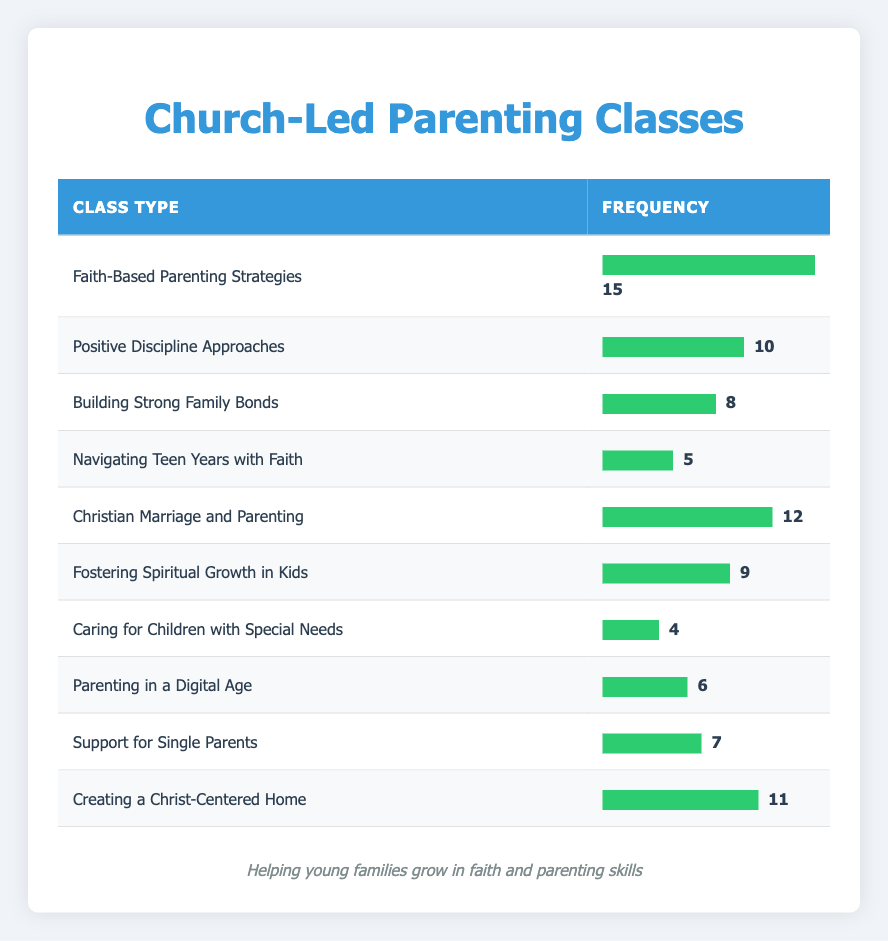What is the most frequently offered class type? The most frequently offered class type can be identified by looking for the maximum frequency value in the table. The class type with the highest frequency is "Faith-Based Parenting Strategies" with a frequency of 15.
Answer: Faith-Based Parenting Strategies How many classes have a frequency of 10 or more? To find the number of classes with a frequency of 10 or more, we count the classes: "Faith-Based Parenting Strategies" (15), "Christian Marriage and Parenting" (12), "Creating a Christ-Centered Home" (11), and "Positive Discipline Approaches" (10). This totals 4 classes.
Answer: 4 What is the frequency difference between "Navigating Teen Years with Faith" and "Caring for Children with Special Needs"? The frequency for "Navigating Teen Years with Faith" is 5, and for "Caring for Children with Special Needs" it is 4. The difference is 5 - 4 = 1.
Answer: 1 Is "Building Strong Family Bonds" offered more frequently than "Fostering Spiritual Growth in Kids"? "Building Strong Family Bonds" has a frequency of 8 while "Fostering Spiritual Growth in Kids" has a frequency of 9. Comparing these values shows that 8 is less than 9, so the statement is false.
Answer: False What is the average frequency of all classes offered? To calculate the average frequency, add together all the frequencies: 15 + 10 + 8 + 5 + 12 + 9 + 4 + 6 + 7 + 11 = 87. There are 10 classes, so the average is 87 / 10 = 8.7.
Answer: 8.7 Which class types are offered less frequently than "Parenting in a Digital Age"? The frequency of "Parenting in a Digital Age" is 6, so we look for classes with a frequency less than 6: "Caring for Children with Special Needs" (4) and "Navigating Teen Years with Faith" (5) fit this criteria. Thus, both are offered less frequently.
Answer: Caring for Children with Special Needs, Navigating Teen Years with Faith How many classes are there in total? To find the total number of classes, we count each unique class type listed in the table. There are 10 classes in total.
Answer: 10 Is there a class specifically for single parents? Looking through the table, there is a class listed as "Support for Single Parents." Thus, the answer to whether there is a class specifically for single parents is yes.
Answer: Yes Which class has the second lowest frequency? The frequencies in ascending order are: "Caring for Children with Special Needs" (4), "Navigating Teen Years with Faith" (5), and "Parenting in a Digital Age" (6). The class with the second lowest frequency is "Navigating Teen Years with Faith."
Answer: Navigating Teen Years with Faith 